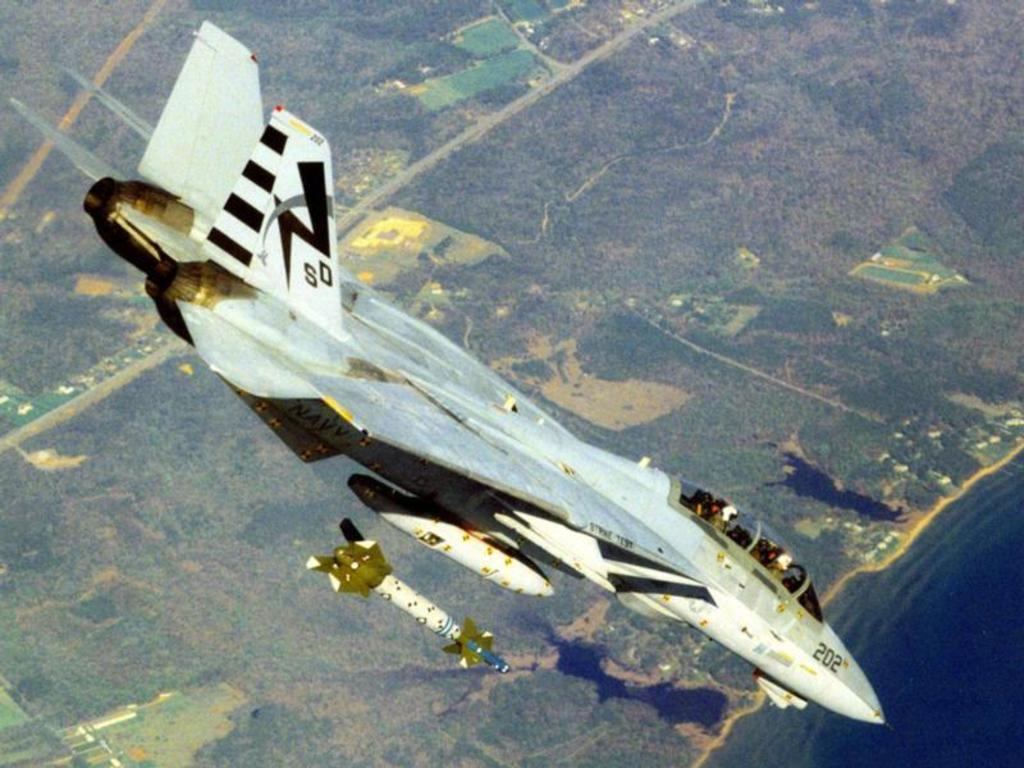<image>
Offer a succinct explanation of the picture presented. A bomb is dropped from a fighter jet with the letters SD and number 202 on it. 